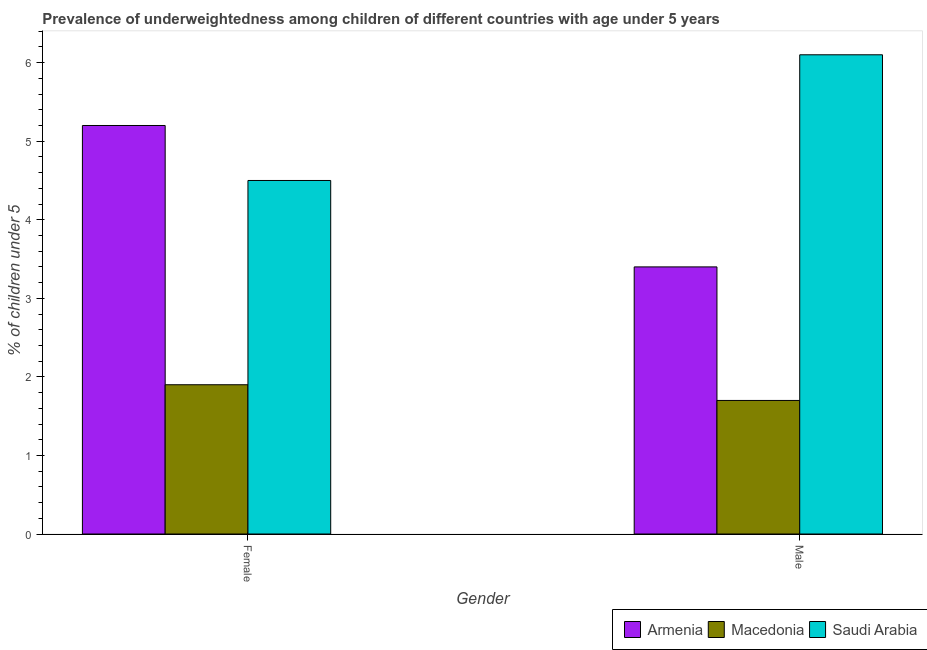How many different coloured bars are there?
Offer a terse response. 3. Are the number of bars on each tick of the X-axis equal?
Your answer should be very brief. Yes. How many bars are there on the 1st tick from the left?
Your answer should be very brief. 3. What is the percentage of underweighted female children in Macedonia?
Your response must be concise. 1.9. Across all countries, what is the maximum percentage of underweighted female children?
Your answer should be very brief. 5.2. Across all countries, what is the minimum percentage of underweighted male children?
Your answer should be very brief. 1.7. In which country was the percentage of underweighted male children maximum?
Provide a short and direct response. Saudi Arabia. In which country was the percentage of underweighted female children minimum?
Make the answer very short. Macedonia. What is the total percentage of underweighted male children in the graph?
Offer a terse response. 11.2. What is the difference between the percentage of underweighted female children in Macedonia and that in Armenia?
Provide a succinct answer. -3.3. What is the difference between the percentage of underweighted male children in Macedonia and the percentage of underweighted female children in Armenia?
Ensure brevity in your answer.  -3.5. What is the average percentage of underweighted female children per country?
Offer a terse response. 3.87. What is the difference between the percentage of underweighted female children and percentage of underweighted male children in Macedonia?
Provide a succinct answer. 0.2. What is the ratio of the percentage of underweighted female children in Macedonia to that in Armenia?
Offer a very short reply. 0.37. What does the 3rd bar from the left in Female represents?
Provide a succinct answer. Saudi Arabia. What does the 2nd bar from the right in Male represents?
Offer a terse response. Macedonia. How many bars are there?
Ensure brevity in your answer.  6. How many countries are there in the graph?
Keep it short and to the point. 3. Does the graph contain any zero values?
Offer a very short reply. No. Does the graph contain grids?
Make the answer very short. No. Where does the legend appear in the graph?
Give a very brief answer. Bottom right. What is the title of the graph?
Provide a short and direct response. Prevalence of underweightedness among children of different countries with age under 5 years. What is the label or title of the Y-axis?
Offer a very short reply.  % of children under 5. What is the  % of children under 5 of Armenia in Female?
Ensure brevity in your answer.  5.2. What is the  % of children under 5 in Macedonia in Female?
Ensure brevity in your answer.  1.9. What is the  % of children under 5 in Armenia in Male?
Ensure brevity in your answer.  3.4. What is the  % of children under 5 of Macedonia in Male?
Offer a very short reply. 1.7. What is the  % of children under 5 of Saudi Arabia in Male?
Your answer should be compact. 6.1. Across all Gender, what is the maximum  % of children under 5 of Armenia?
Your response must be concise. 5.2. Across all Gender, what is the maximum  % of children under 5 of Macedonia?
Offer a very short reply. 1.9. Across all Gender, what is the maximum  % of children under 5 in Saudi Arabia?
Your answer should be very brief. 6.1. Across all Gender, what is the minimum  % of children under 5 in Armenia?
Make the answer very short. 3.4. Across all Gender, what is the minimum  % of children under 5 in Macedonia?
Give a very brief answer. 1.7. Across all Gender, what is the minimum  % of children under 5 of Saudi Arabia?
Provide a succinct answer. 4.5. What is the difference between the  % of children under 5 of Macedonia in Female and that in Male?
Offer a terse response. 0.2. What is the average  % of children under 5 of Armenia per Gender?
Offer a terse response. 4.3. What is the average  % of children under 5 of Saudi Arabia per Gender?
Your answer should be very brief. 5.3. What is the difference between the  % of children under 5 of Armenia and  % of children under 5 of Macedonia in Female?
Ensure brevity in your answer.  3.3. What is the difference between the  % of children under 5 in Armenia and  % of children under 5 in Saudi Arabia in Female?
Offer a very short reply. 0.7. What is the difference between the  % of children under 5 of Armenia and  % of children under 5 of Macedonia in Male?
Offer a terse response. 1.7. What is the ratio of the  % of children under 5 in Armenia in Female to that in Male?
Keep it short and to the point. 1.53. What is the ratio of the  % of children under 5 of Macedonia in Female to that in Male?
Offer a very short reply. 1.12. What is the ratio of the  % of children under 5 of Saudi Arabia in Female to that in Male?
Your answer should be compact. 0.74. What is the difference between the highest and the lowest  % of children under 5 in Macedonia?
Offer a terse response. 0.2. What is the difference between the highest and the lowest  % of children under 5 in Saudi Arabia?
Give a very brief answer. 1.6. 